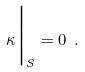<formula> <loc_0><loc_0><loc_500><loc_500>\kappa \Big | _ { S } = 0 \ .</formula> 